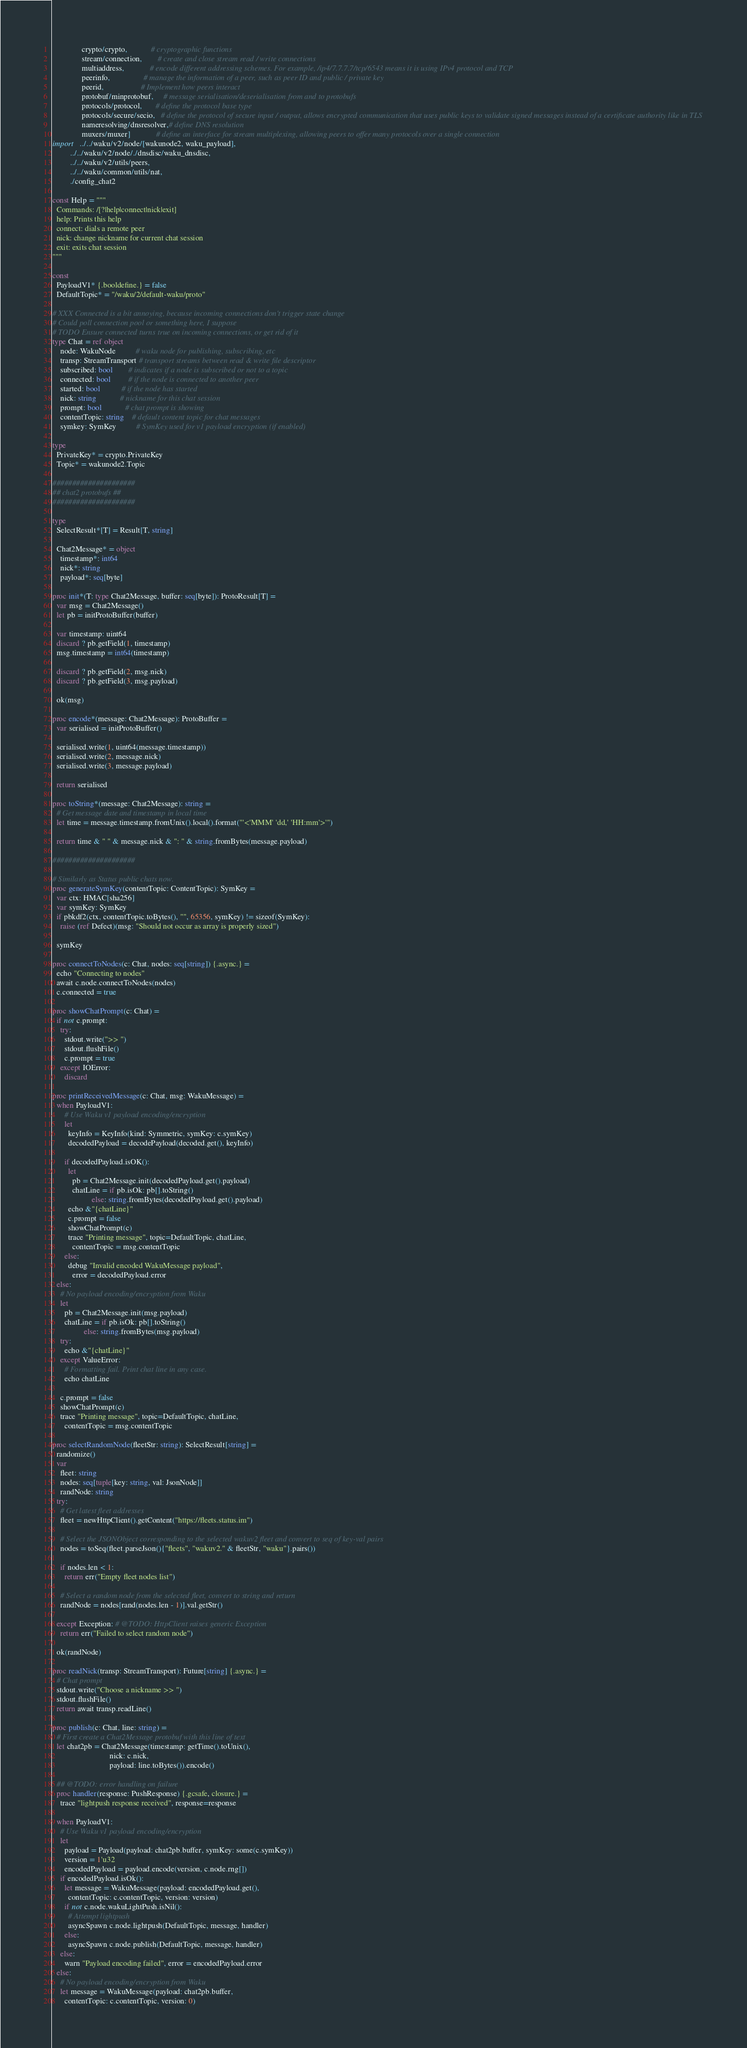Convert code to text. <code><loc_0><loc_0><loc_500><loc_500><_Nim_>               crypto/crypto,            # cryptographic functions
               stream/connection,        # create and close stream read / write connections
               multiaddress,             # encode different addressing schemes. For example, /ip4/7.7.7.7/tcp/6543 means it is using IPv4 protocol and TCP
               peerinfo,                 # manage the information of a peer, such as peer ID and public / private key
               peerid,                   # Implement how peers interact
               protobuf/minprotobuf,     # message serialisation/deserialisation from and to protobufs
               protocols/protocol,       # define the protocol base type
               protocols/secure/secio,   # define the protocol of secure input / output, allows encrypted communication that uses public keys to validate signed messages instead of a certificate authority like in TLS
               nameresolving/dnsresolver,# define DNS resolution
               muxers/muxer]             # define an interface for stream multiplexing, allowing peers to offer many protocols over a single connection
import   ../../waku/v2/node/[wakunode2, waku_payload],
         ../../waku/v2/node/./dnsdisc/waku_dnsdisc,
         ../../waku/v2/utils/peers,
         ../../waku/common/utils/nat,
         ./config_chat2

const Help = """
  Commands: /[?|help|connect|nick|exit]
  help: Prints this help
  connect: dials a remote peer
  nick: change nickname for current chat session
  exit: exits chat session
"""

const
  PayloadV1* {.booldefine.} = false
  DefaultTopic* = "/waku/2/default-waku/proto"

# XXX Connected is a bit annoying, because incoming connections don't trigger state change
# Could poll connection pool or something here, I suppose
# TODO Ensure connected turns true on incoming connections, or get rid of it
type Chat = ref object
    node: WakuNode          # waku node for publishing, subscribing, etc
    transp: StreamTransport # transport streams between read & write file descriptor
    subscribed: bool        # indicates if a node is subscribed or not to a topic
    connected: bool         # if the node is connected to another peer
    started: bool           # if the node has started
    nick: string            # nickname for this chat session
    prompt: bool            # chat prompt is showing
    contentTopic: string    # default content topic for chat messages
    symkey: SymKey          # SymKey used for v1 payload encryption (if enabled)

type
  PrivateKey* = crypto.PrivateKey
  Topic* = wakunode2.Topic

#####################
## chat2 protobufs ##
#####################

type
  SelectResult*[T] = Result[T, string]

  Chat2Message* = object
    timestamp*: int64
    nick*: string
    payload*: seq[byte]

proc init*(T: type Chat2Message, buffer: seq[byte]): ProtoResult[T] =
  var msg = Chat2Message()
  let pb = initProtoBuffer(buffer)

  var timestamp: uint64
  discard ? pb.getField(1, timestamp)
  msg.timestamp = int64(timestamp)

  discard ? pb.getField(2, msg.nick)
  discard ? pb.getField(3, msg.payload)

  ok(msg)

proc encode*(message: Chat2Message): ProtoBuffer =
  var serialised = initProtoBuffer()

  serialised.write(1, uint64(message.timestamp))
  serialised.write(2, message.nick)
  serialised.write(3, message.payload)

  return serialised

proc toString*(message: Chat2Message): string =
  # Get message date and timestamp in local time
  let time = message.timestamp.fromUnix().local().format("'<'MMM' 'dd,' 'HH:mm'>'")

  return time & " " & message.nick & ": " & string.fromBytes(message.payload)

#####################

# Similarly as Status public chats now.
proc generateSymKey(contentTopic: ContentTopic): SymKey =
  var ctx: HMAC[sha256]
  var symKey: SymKey
  if pbkdf2(ctx, contentTopic.toBytes(), "", 65356, symKey) != sizeof(SymKey):
    raise (ref Defect)(msg: "Should not occur as array is properly sized")

  symKey

proc connectToNodes(c: Chat, nodes: seq[string]) {.async.} =
  echo "Connecting to nodes"
  await c.node.connectToNodes(nodes)
  c.connected = true

proc showChatPrompt(c: Chat) =
  if not c.prompt:
    try:
      stdout.write(">> ")
      stdout.flushFile()
      c.prompt = true
    except IOError:
      discard

proc printReceivedMessage(c: Chat, msg: WakuMessage) =
  when PayloadV1:
      # Use Waku v1 payload encoding/encryption
      let
        keyInfo = KeyInfo(kind: Symmetric, symKey: c.symKey)
        decodedPayload = decodePayload(decoded.get(), keyInfo)

      if decodedPayload.isOK():
        let
          pb = Chat2Message.init(decodedPayload.get().payload)
          chatLine = if pb.isOk: pb[].toString()
                    else: string.fromBytes(decodedPayload.get().payload)
        echo &"{chatLine}"
        c.prompt = false
        showChatPrompt(c)
        trace "Printing message", topic=DefaultTopic, chatLine,
          contentTopic = msg.contentTopic
      else:
        debug "Invalid encoded WakuMessage payload",
          error = decodedPayload.error
  else:
    # No payload encoding/encryption from Waku
    let
      pb = Chat2Message.init(msg.payload)
      chatLine = if pb.isOk: pb[].toString()
                else: string.fromBytes(msg.payload)
    try:
      echo &"{chatLine}"
    except ValueError:
      # Formatting fail. Print chat line in any case.
      echo chatLine
    
    c.prompt = false
    showChatPrompt(c)
    trace "Printing message", topic=DefaultTopic, chatLine,
      contentTopic = msg.contentTopic

proc selectRandomNode(fleetStr: string): SelectResult[string] =
  randomize()
  var
    fleet: string
    nodes: seq[tuple[key: string, val: JsonNode]]
    randNode: string
  try:
    # Get latest fleet addresses
    fleet = newHttpClient().getContent("https://fleets.status.im")
  
    # Select the JSONObject corresponding to the selected wakuv2 fleet and convert to seq of key-val pairs
    nodes = toSeq(fleet.parseJson(){"fleets", "wakuv2." & fleetStr, "waku"}.pairs())
  
    if nodes.len < 1:
      return err("Empty fleet nodes list")

    # Select a random node from the selected fleet, convert to string and return
    randNode = nodes[rand(nodes.len - 1)].val.getStr()
  
  except Exception: # @TODO: HttpClient raises generic Exception
    return err("Failed to select random node")
  
  ok(randNode)

proc readNick(transp: StreamTransport): Future[string] {.async.} =
  # Chat prompt
  stdout.write("Choose a nickname >> ")
  stdout.flushFile()
  return await transp.readLine()

proc publish(c: Chat, line: string) =
  # First create a Chat2Message protobuf with this line of text
  let chat2pb = Chat2Message(timestamp: getTime().toUnix(),
                             nick: c.nick,
                             payload: line.toBytes()).encode()

  ## @TODO: error handling on failure
  proc handler(response: PushResponse) {.gcsafe, closure.} =
    trace "lightpush response received", response=response

  when PayloadV1:
    # Use Waku v1 payload encoding/encryption
    let
      payload = Payload(payload: chat2pb.buffer, symKey: some(c.symKey))
      version = 1'u32
      encodedPayload = payload.encode(version, c.node.rng[])
    if encodedPayload.isOk():
      let message = WakuMessage(payload: encodedPayload.get(),
        contentTopic: c.contentTopic, version: version)
      if not c.node.wakuLightPush.isNil():
        # Attempt lightpush
        asyncSpawn c.node.lightpush(DefaultTopic, message, handler)
      else:
        asyncSpawn c.node.publish(DefaultTopic, message, handler)
    else:
      warn "Payload encoding failed", error = encodedPayload.error
  else:
    # No payload encoding/encryption from Waku
    let message = WakuMessage(payload: chat2pb.buffer,
      contentTopic: c.contentTopic, version: 0)</code> 